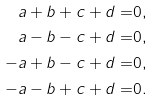Convert formula to latex. <formula><loc_0><loc_0><loc_500><loc_500>a + b + c + d = & 0 , \\ a - b - c + d = & 0 , \\ - a + b - c + d = & 0 , \\ - a - b + c + d = & 0 .</formula> 